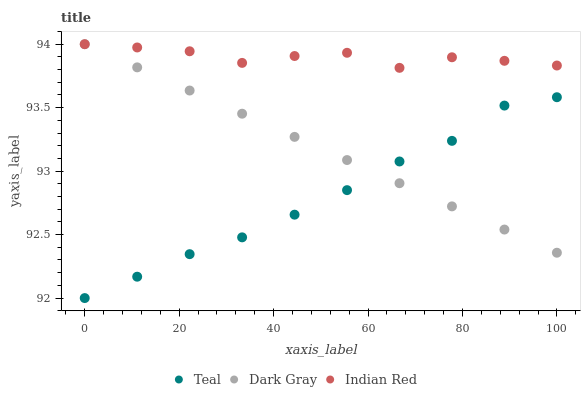Does Teal have the minimum area under the curve?
Answer yes or no. Yes. Does Indian Red have the maximum area under the curve?
Answer yes or no. Yes. Does Indian Red have the minimum area under the curve?
Answer yes or no. No. Does Teal have the maximum area under the curve?
Answer yes or no. No. Is Dark Gray the smoothest?
Answer yes or no. Yes. Is Indian Red the roughest?
Answer yes or no. Yes. Is Teal the smoothest?
Answer yes or no. No. Is Teal the roughest?
Answer yes or no. No. Does Teal have the lowest value?
Answer yes or no. Yes. Does Indian Red have the lowest value?
Answer yes or no. No. Does Indian Red have the highest value?
Answer yes or no. Yes. Does Teal have the highest value?
Answer yes or no. No. Is Teal less than Indian Red?
Answer yes or no. Yes. Is Indian Red greater than Teal?
Answer yes or no. Yes. Does Teal intersect Dark Gray?
Answer yes or no. Yes. Is Teal less than Dark Gray?
Answer yes or no. No. Is Teal greater than Dark Gray?
Answer yes or no. No. Does Teal intersect Indian Red?
Answer yes or no. No. 